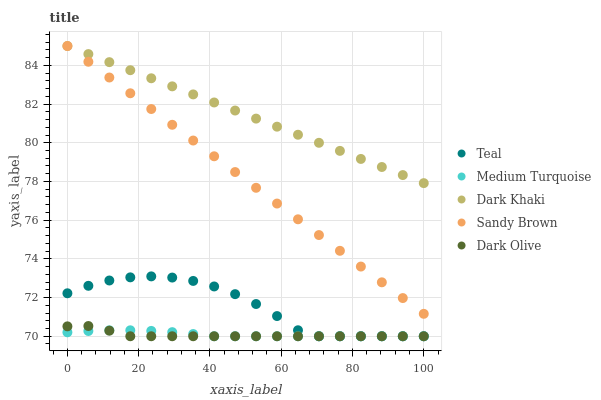Does Dark Olive have the minimum area under the curve?
Answer yes or no. Yes. Does Dark Khaki have the maximum area under the curve?
Answer yes or no. Yes. Does Sandy Brown have the minimum area under the curve?
Answer yes or no. No. Does Sandy Brown have the maximum area under the curve?
Answer yes or no. No. Is Dark Khaki the smoothest?
Answer yes or no. Yes. Is Teal the roughest?
Answer yes or no. Yes. Is Dark Olive the smoothest?
Answer yes or no. No. Is Dark Olive the roughest?
Answer yes or no. No. Does Dark Olive have the lowest value?
Answer yes or no. Yes. Does Sandy Brown have the lowest value?
Answer yes or no. No. Does Sandy Brown have the highest value?
Answer yes or no. Yes. Does Dark Olive have the highest value?
Answer yes or no. No. Is Teal less than Sandy Brown?
Answer yes or no. Yes. Is Sandy Brown greater than Teal?
Answer yes or no. Yes. Does Sandy Brown intersect Dark Khaki?
Answer yes or no. Yes. Is Sandy Brown less than Dark Khaki?
Answer yes or no. No. Is Sandy Brown greater than Dark Khaki?
Answer yes or no. No. Does Teal intersect Sandy Brown?
Answer yes or no. No. 